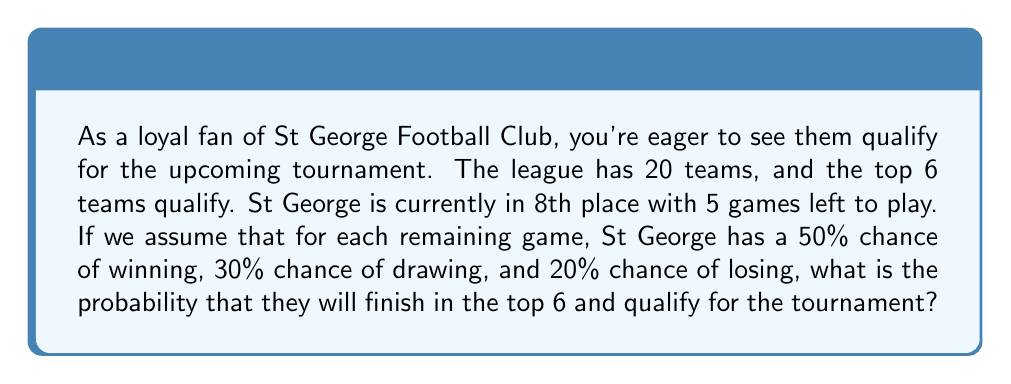Can you solve this math problem? Let's break this down step-by-step:

1) First, we need to calculate the possible outcomes for St George in their remaining 5 games. We can use the binomial probability formula for this.

2) Let's define:
   $p(win) = 0.5$
   $p(draw) = 0.3$
   $p(loss) = 0.2$

3) To simplify, let's assume that St George needs to win at least 4 out of 5 games to move up to 6th place or higher. (This is a simplification for the sake of the problem.)

4) The probability of winning exactly 4 games out of 5 is:

   $$P(4 wins) = \binom{5}{4} * 0.5^4 * 0.5^1 = 5 * 0.0625 * 0.5 = 0.15625$$

5) The probability of winning all 5 games is:

   $$P(5 wins) = 0.5^5 = 0.03125$$

6) Therefore, the total probability of winning at least 4 games is:

   $$P(at least 4 wins) = P(4 wins) + P(5 wins) = 0.15625 + 0.03125 = 0.1875$$

7) This means St George has approximately an 18.75% chance of qualifying for the tournament under these assumptions.
Answer: The probability that St George Football Club will qualify for the tournament is approximately 0.1875 or 18.75%. 